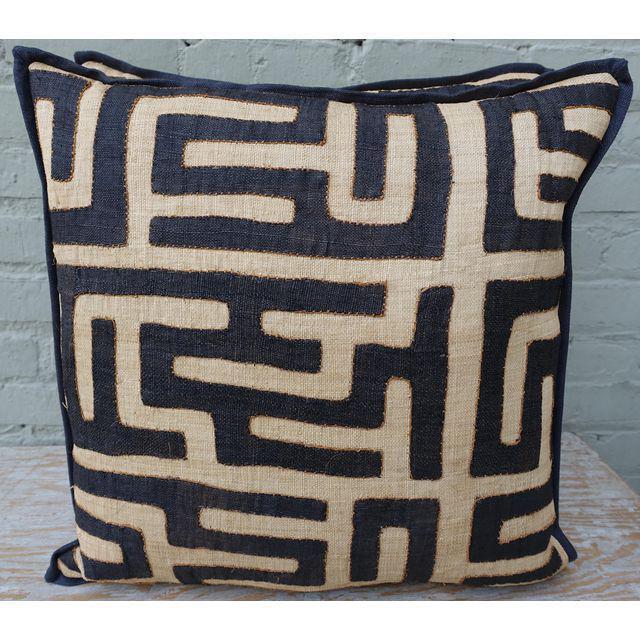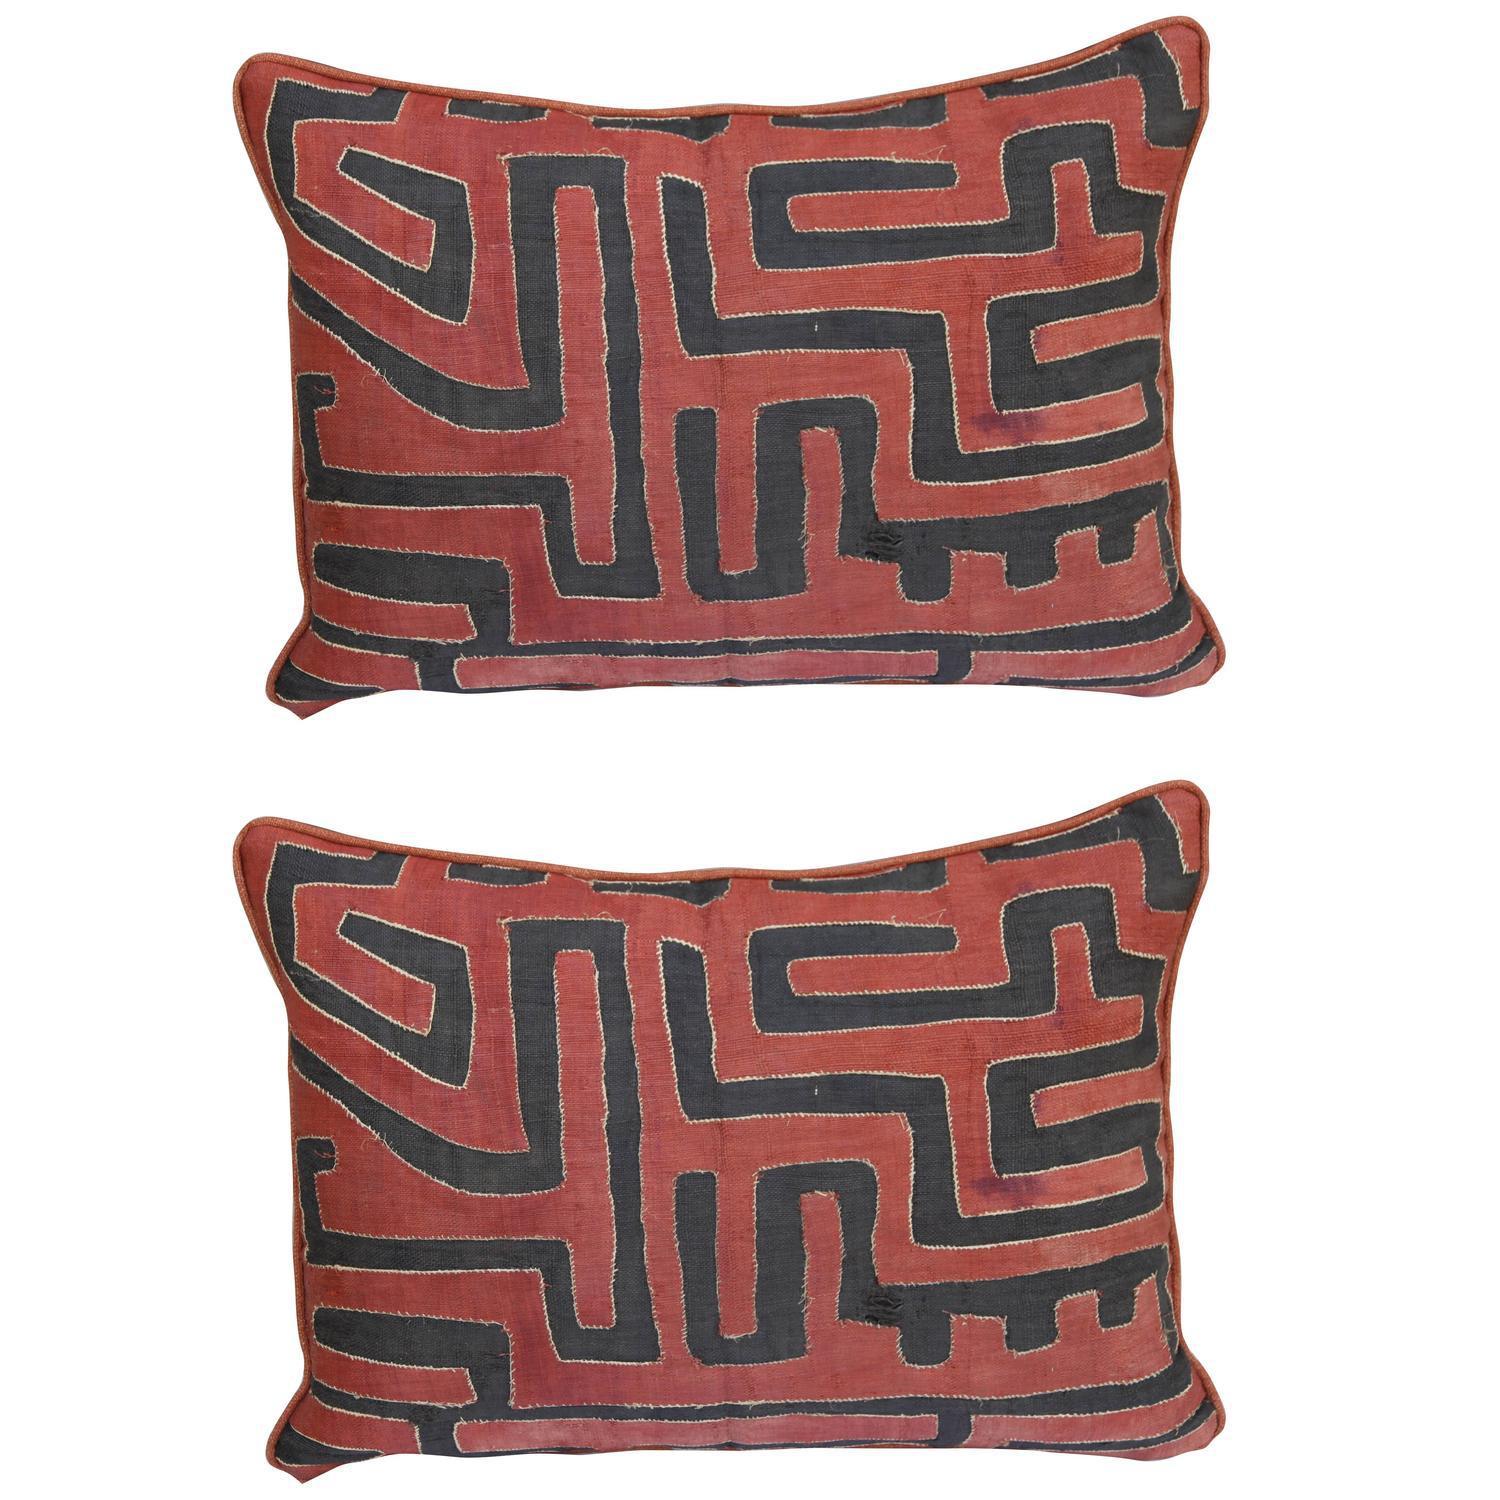The first image is the image on the left, the second image is the image on the right. Evaluate the accuracy of this statement regarding the images: "There are three pillows in the two images.". Is it true? Answer yes or no. Yes. The first image is the image on the left, the second image is the image on the right. Examine the images to the left and right. Is the description "All pillows feature a graphic print resembling a maze, and no image contains multiple pillows that don't match." accurate? Answer yes or no. Yes. 